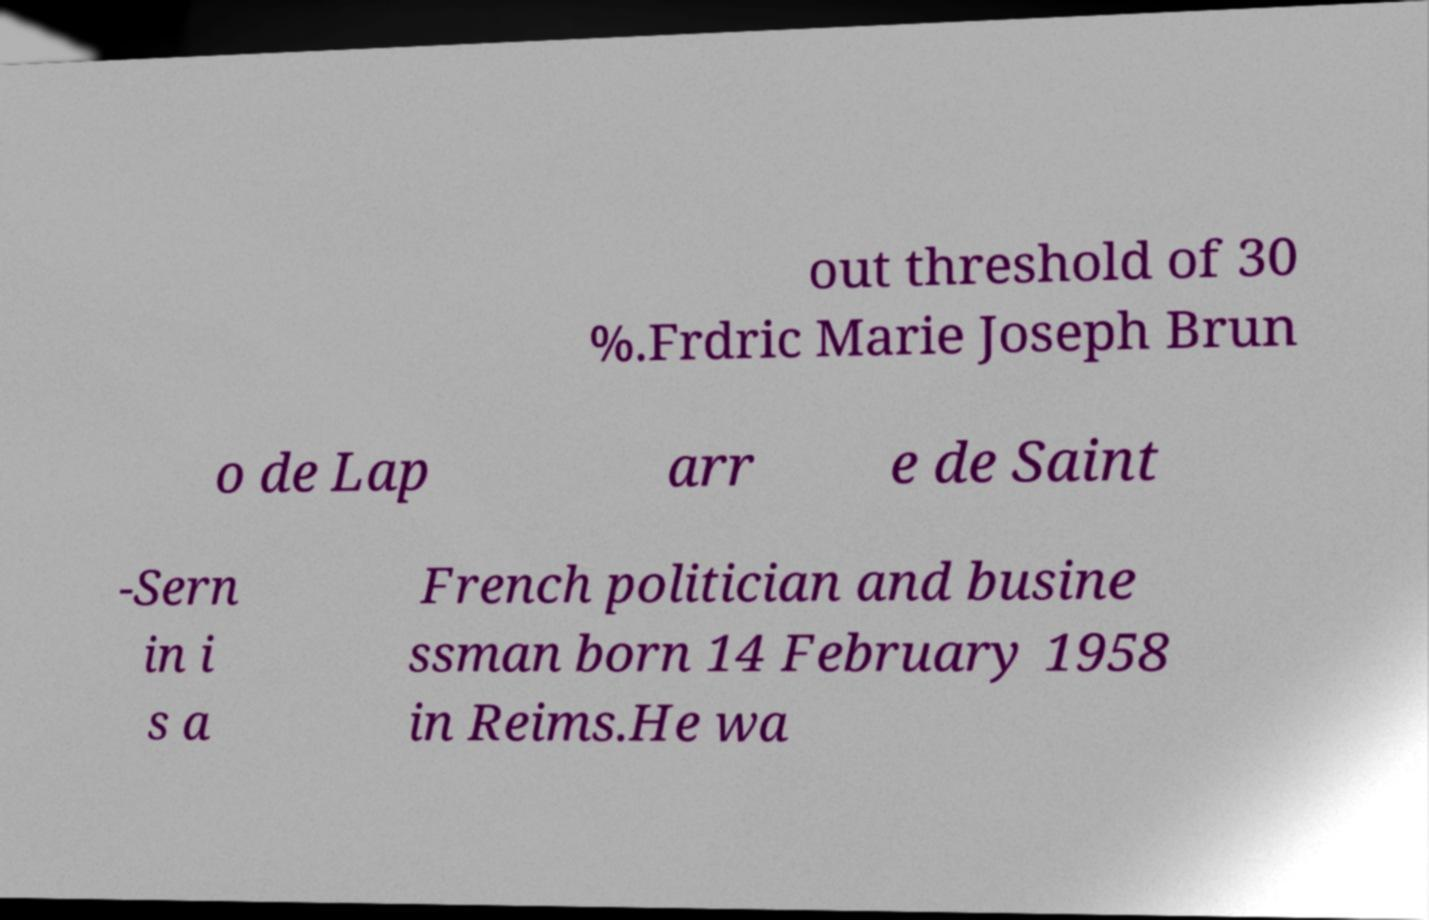Could you assist in decoding the text presented in this image and type it out clearly? out threshold of 30 %.Frdric Marie Joseph Brun o de Lap arr e de Saint -Sern in i s a French politician and busine ssman born 14 February 1958 in Reims.He wa 